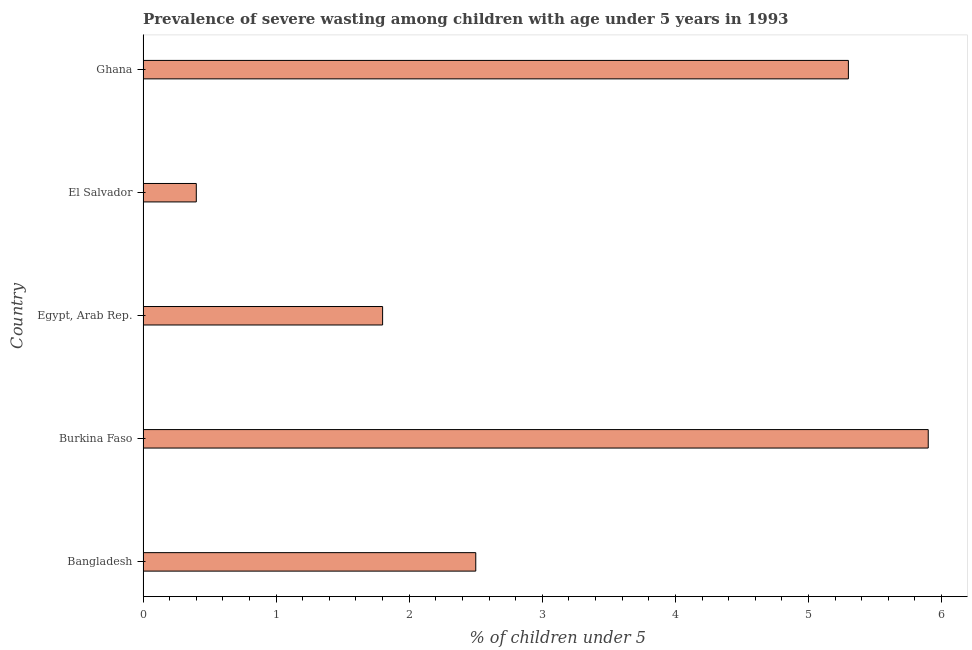What is the title of the graph?
Ensure brevity in your answer.  Prevalence of severe wasting among children with age under 5 years in 1993. What is the label or title of the X-axis?
Ensure brevity in your answer.   % of children under 5. What is the label or title of the Y-axis?
Your answer should be compact. Country. What is the prevalence of severe wasting in Egypt, Arab Rep.?
Give a very brief answer. 1.8. Across all countries, what is the maximum prevalence of severe wasting?
Make the answer very short. 5.9. Across all countries, what is the minimum prevalence of severe wasting?
Your response must be concise. 0.4. In which country was the prevalence of severe wasting maximum?
Give a very brief answer. Burkina Faso. In which country was the prevalence of severe wasting minimum?
Give a very brief answer. El Salvador. What is the sum of the prevalence of severe wasting?
Make the answer very short. 15.9. What is the difference between the prevalence of severe wasting in Bangladesh and El Salvador?
Keep it short and to the point. 2.1. What is the average prevalence of severe wasting per country?
Your response must be concise. 3.18. In how many countries, is the prevalence of severe wasting greater than 5.8 %?
Make the answer very short. 1. What is the ratio of the prevalence of severe wasting in Bangladesh to that in Burkina Faso?
Offer a very short reply. 0.42. Is the prevalence of severe wasting in El Salvador less than that in Ghana?
Ensure brevity in your answer.  Yes. Is the sum of the prevalence of severe wasting in Burkina Faso and Ghana greater than the maximum prevalence of severe wasting across all countries?
Give a very brief answer. Yes. What is the difference between the highest and the lowest prevalence of severe wasting?
Offer a very short reply. 5.5. In how many countries, is the prevalence of severe wasting greater than the average prevalence of severe wasting taken over all countries?
Ensure brevity in your answer.  2. Are all the bars in the graph horizontal?
Keep it short and to the point. Yes. Are the values on the major ticks of X-axis written in scientific E-notation?
Provide a short and direct response. No. What is the  % of children under 5 of Burkina Faso?
Make the answer very short. 5.9. What is the  % of children under 5 in Egypt, Arab Rep.?
Your response must be concise. 1.8. What is the  % of children under 5 of El Salvador?
Provide a succinct answer. 0.4. What is the  % of children under 5 in Ghana?
Provide a succinct answer. 5.3. What is the difference between the  % of children under 5 in Bangladesh and Burkina Faso?
Provide a short and direct response. -3.4. What is the difference between the  % of children under 5 in Bangladesh and Egypt, Arab Rep.?
Provide a succinct answer. 0.7. What is the difference between the  % of children under 5 in Bangladesh and El Salvador?
Provide a short and direct response. 2.1. What is the difference between the  % of children under 5 in Bangladesh and Ghana?
Make the answer very short. -2.8. What is the difference between the  % of children under 5 in Burkina Faso and Egypt, Arab Rep.?
Keep it short and to the point. 4.1. What is the difference between the  % of children under 5 in Burkina Faso and El Salvador?
Offer a very short reply. 5.5. What is the difference between the  % of children under 5 in Egypt, Arab Rep. and El Salvador?
Offer a very short reply. 1.4. What is the difference between the  % of children under 5 in Egypt, Arab Rep. and Ghana?
Give a very brief answer. -3.5. What is the ratio of the  % of children under 5 in Bangladesh to that in Burkina Faso?
Offer a very short reply. 0.42. What is the ratio of the  % of children under 5 in Bangladesh to that in Egypt, Arab Rep.?
Your answer should be very brief. 1.39. What is the ratio of the  % of children under 5 in Bangladesh to that in El Salvador?
Ensure brevity in your answer.  6.25. What is the ratio of the  % of children under 5 in Bangladesh to that in Ghana?
Offer a terse response. 0.47. What is the ratio of the  % of children under 5 in Burkina Faso to that in Egypt, Arab Rep.?
Provide a short and direct response. 3.28. What is the ratio of the  % of children under 5 in Burkina Faso to that in El Salvador?
Ensure brevity in your answer.  14.75. What is the ratio of the  % of children under 5 in Burkina Faso to that in Ghana?
Your answer should be very brief. 1.11. What is the ratio of the  % of children under 5 in Egypt, Arab Rep. to that in El Salvador?
Your response must be concise. 4.5. What is the ratio of the  % of children under 5 in Egypt, Arab Rep. to that in Ghana?
Your answer should be compact. 0.34. What is the ratio of the  % of children under 5 in El Salvador to that in Ghana?
Give a very brief answer. 0.07. 